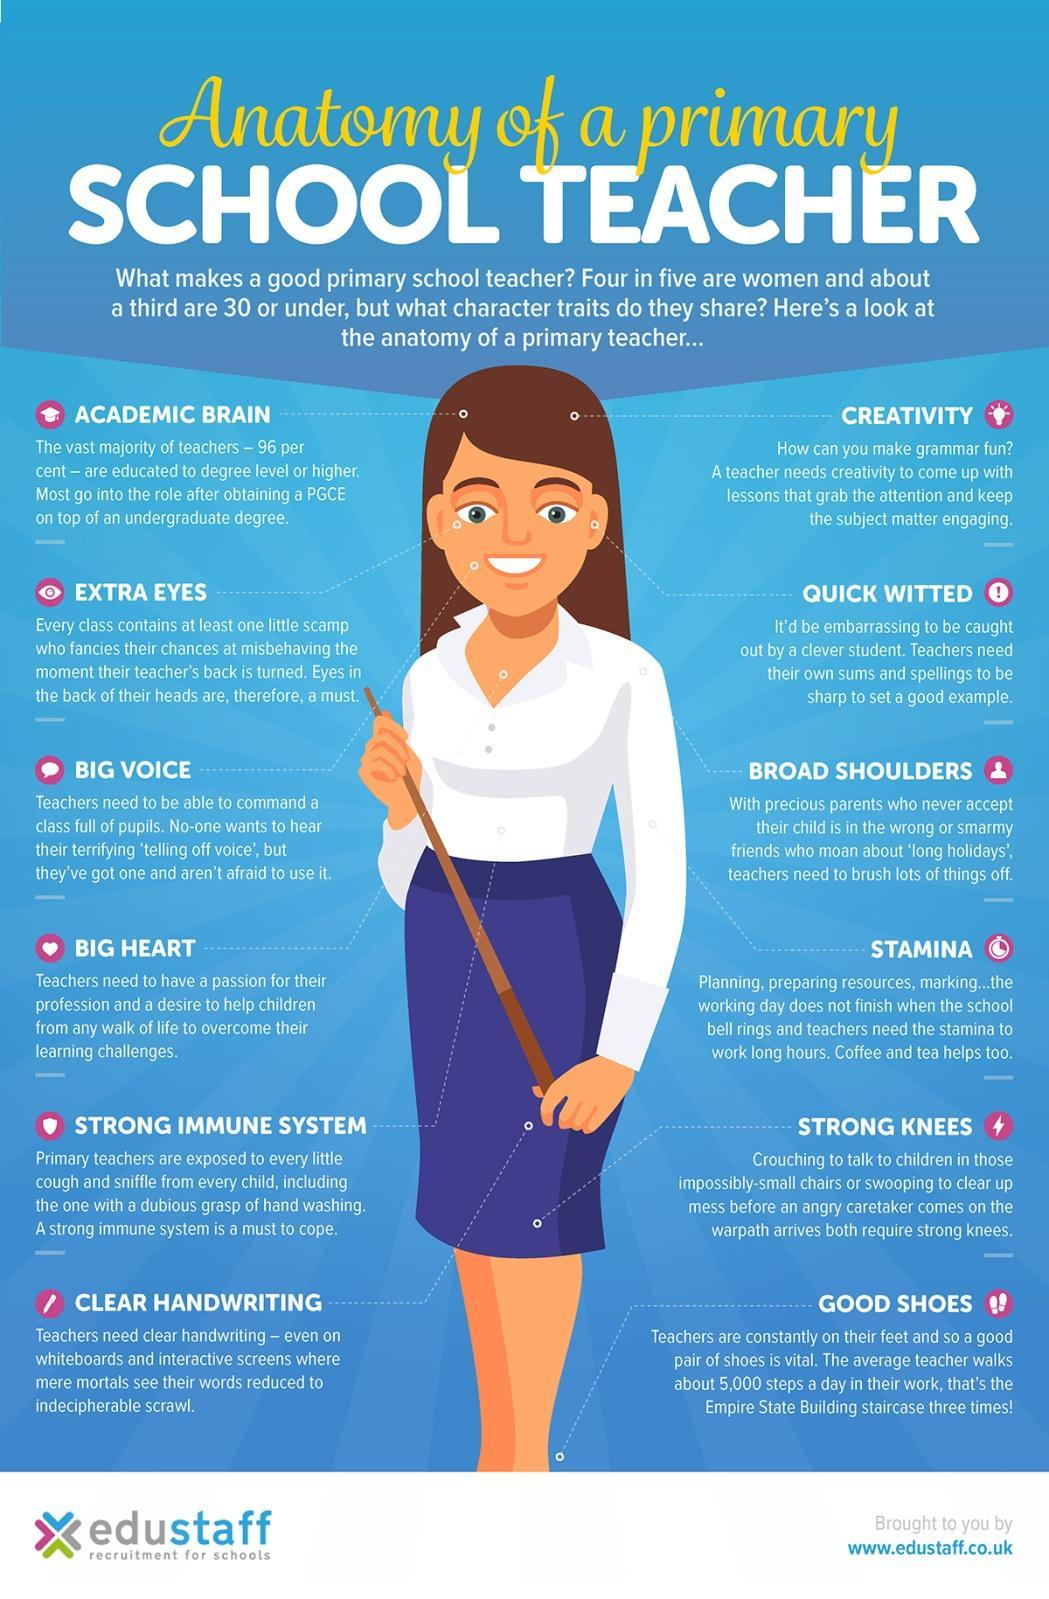Which drink provides extra stamina to Primary teachers?
Answer the question with a short phrase. Coffee and Tea 